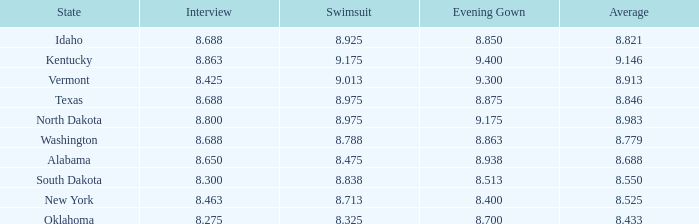What is the smallest night score of the competitor with a night gown under None. 